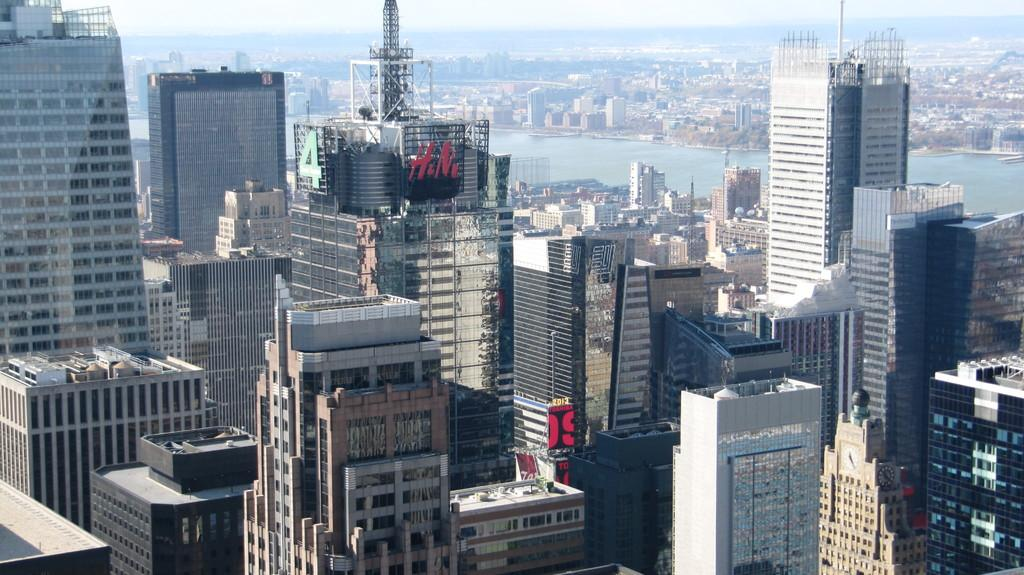What type of structures are present in the image? There are buildings in the image. What feature can be seen on the buildings? The buildings have windows. What natural element is visible in the image? There is water visible in the image. What part of the environment can be seen in the image? The sky is visible in the image. How many women are carrying bags in the image? There are no women or bags present in the image. 